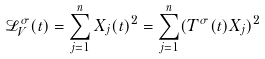<formula> <loc_0><loc_0><loc_500><loc_500>\mathcal { L } _ { V } ^ { \sigma } ( t ) = \sum _ { j = 1 } ^ { n } X _ { j } ( t ) ^ { 2 } = \sum _ { j = 1 } ^ { n } ( T ^ { \sigma } ( t ) X _ { j } ) ^ { 2 }</formula> 